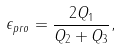Convert formula to latex. <formula><loc_0><loc_0><loc_500><loc_500>\epsilon _ { p r o } = \frac { 2 Q _ { 1 } } { Q _ { 2 } + Q _ { 3 } } ,</formula> 